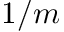Convert formula to latex. <formula><loc_0><loc_0><loc_500><loc_500>1 / m</formula> 